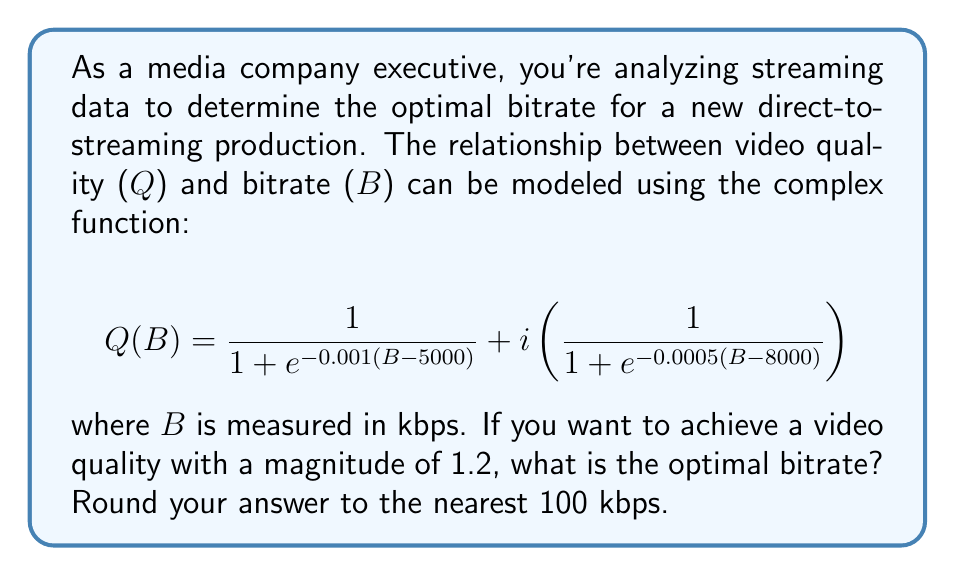Could you help me with this problem? To solve this problem, we need to follow these steps:

1) The magnitude of a complex number $z = a + bi$ is given by $|z| = \sqrt{a^2 + b^2}$.

2) We want $|Q(B)| = 1.2$, so we need to solve:

   $$\sqrt{\left(\frac{1}{1 + e^{-0.001(B - 5000)}}\right)^2 + \left(\frac{1}{1 + e^{-0.0005(B - 8000)}}\right)^2} = 1.2$$

3) Square both sides:

   $$\left(\frac{1}{1 + e^{-0.001(B - 5000)}}\right)^2 + \left(\frac{1}{1 + e^{-0.0005(B - 8000)}}\right)^2 = 1.44$$

4) This equation is too complex to solve algebraically, so we need to use numerical methods. We can use a graphing calculator or a computer program to plot the left side of the equation and find where it intersects y = 1.44.

5) Using such methods, we find that the equation is satisfied when B ≈ 7251 kbps.

6) Rounding to the nearest 100 kbps, we get 7300 kbps.
Answer: The optimal bitrate is approximately 7300 kbps. 